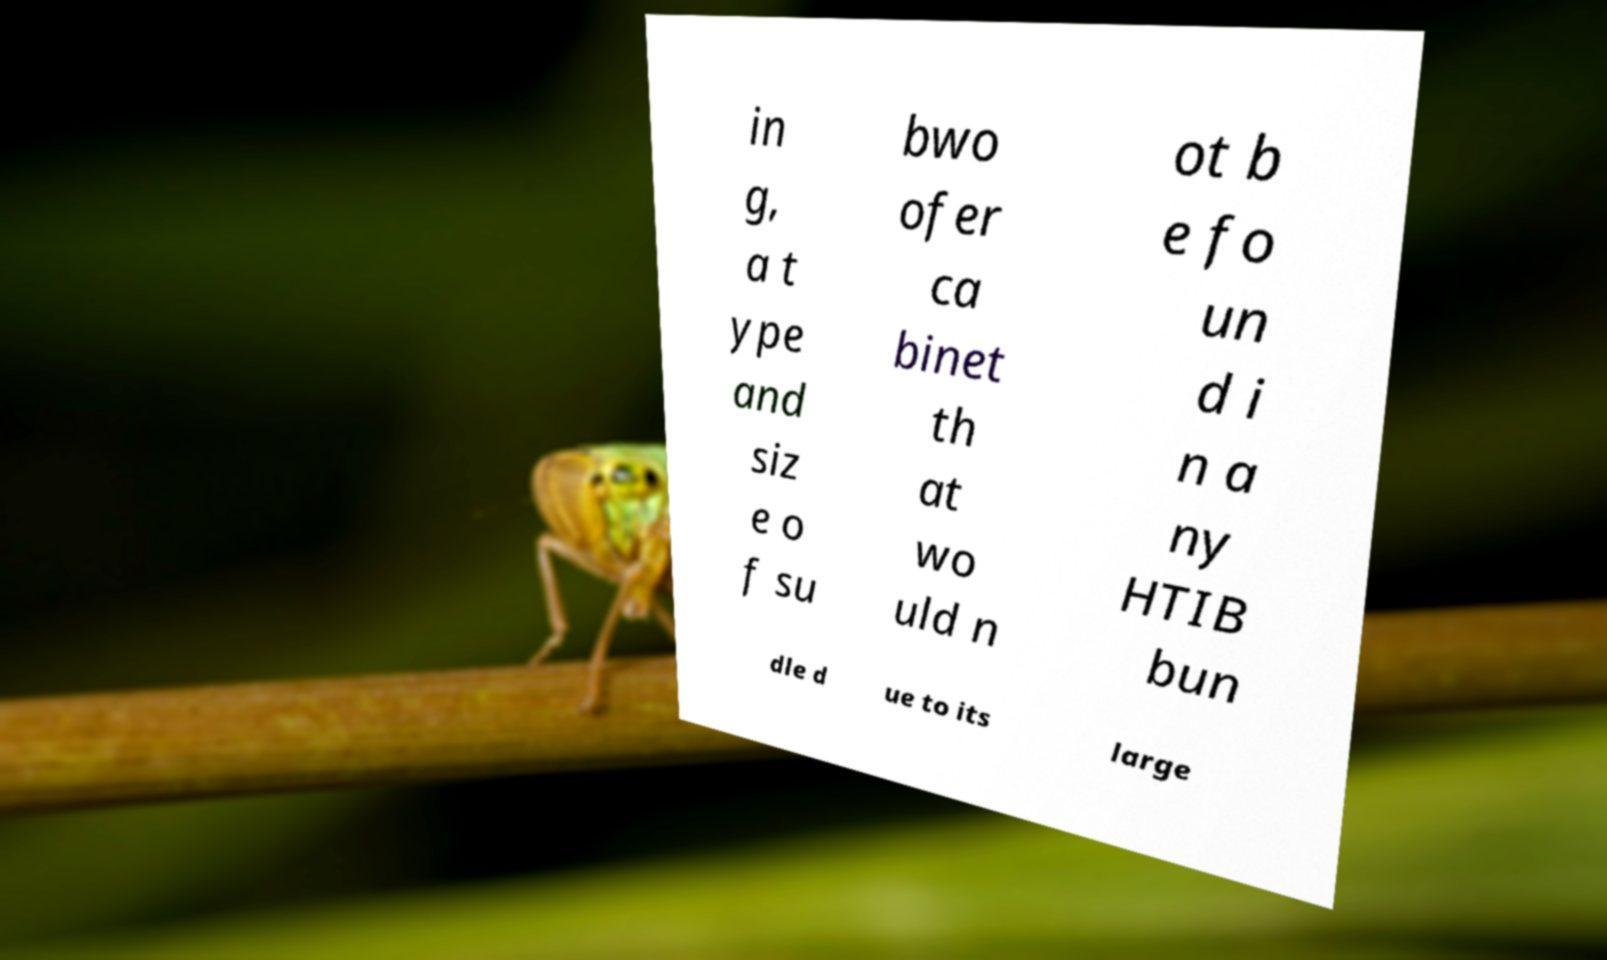There's text embedded in this image that I need extracted. Can you transcribe it verbatim? in g, a t ype and siz e o f su bwo ofer ca binet th at wo uld n ot b e fo un d i n a ny HTIB bun dle d ue to its large 